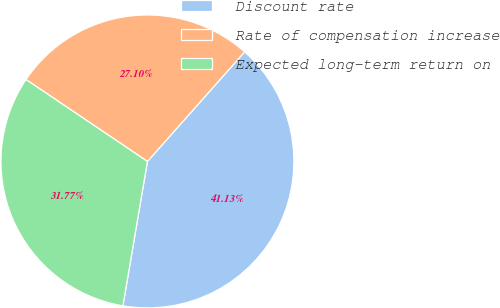<chart> <loc_0><loc_0><loc_500><loc_500><pie_chart><fcel>Discount rate<fcel>Rate of compensation increase<fcel>Expected long-term return on<nl><fcel>41.13%<fcel>27.1%<fcel>31.77%<nl></chart> 